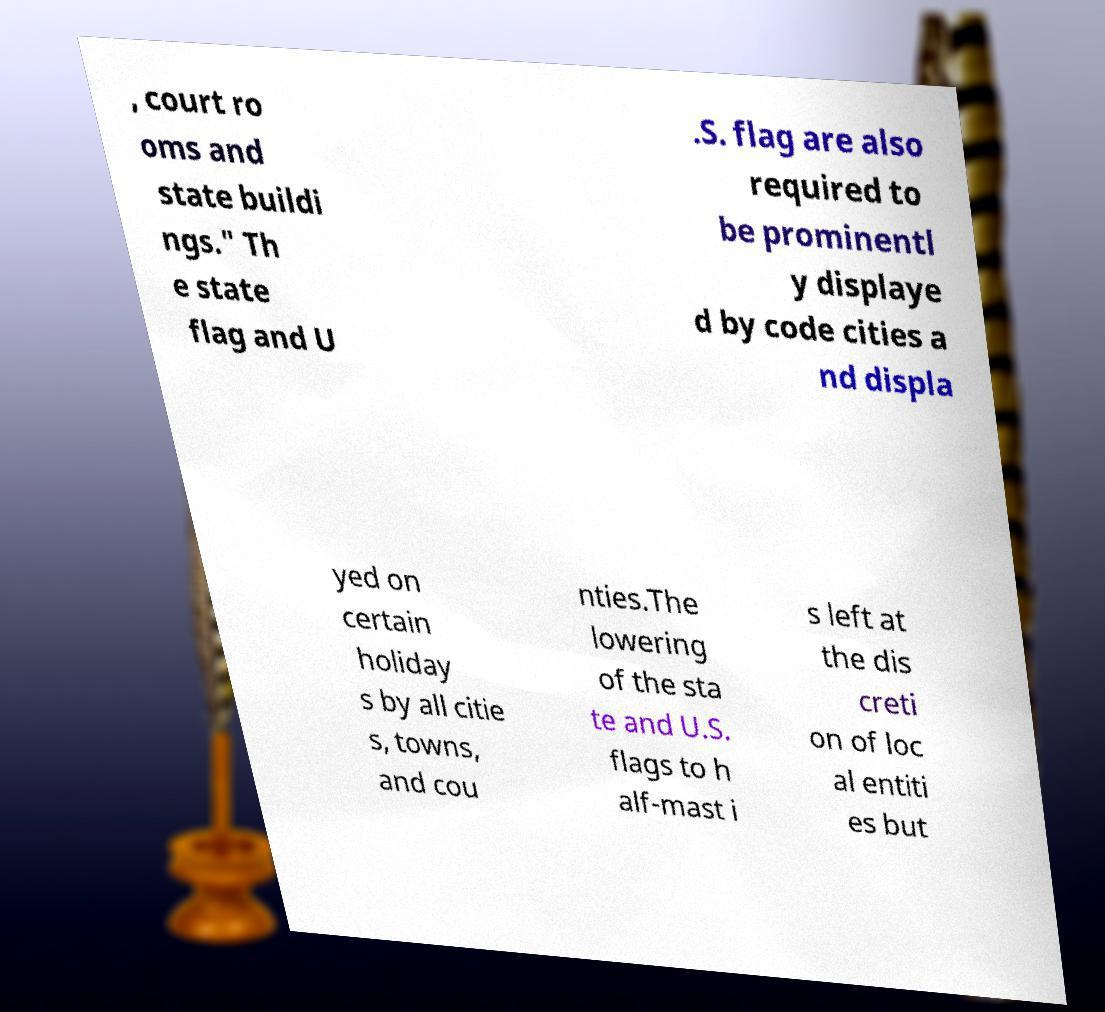What messages or text are displayed in this image? I need them in a readable, typed format. , court ro oms and state buildi ngs." Th e state flag and U .S. flag are also required to be prominentl y displaye d by code cities a nd displa yed on certain holiday s by all citie s, towns, and cou nties.The lowering of the sta te and U.S. flags to h alf-mast i s left at the dis creti on of loc al entiti es but 